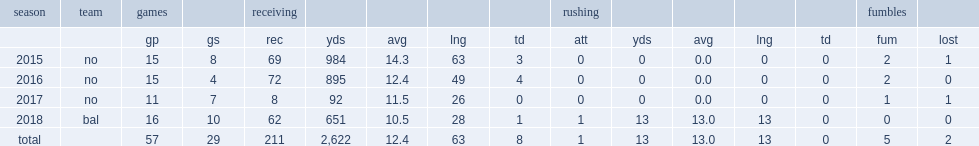How many receptions did willie snead iv get in 2015? 69.0. 